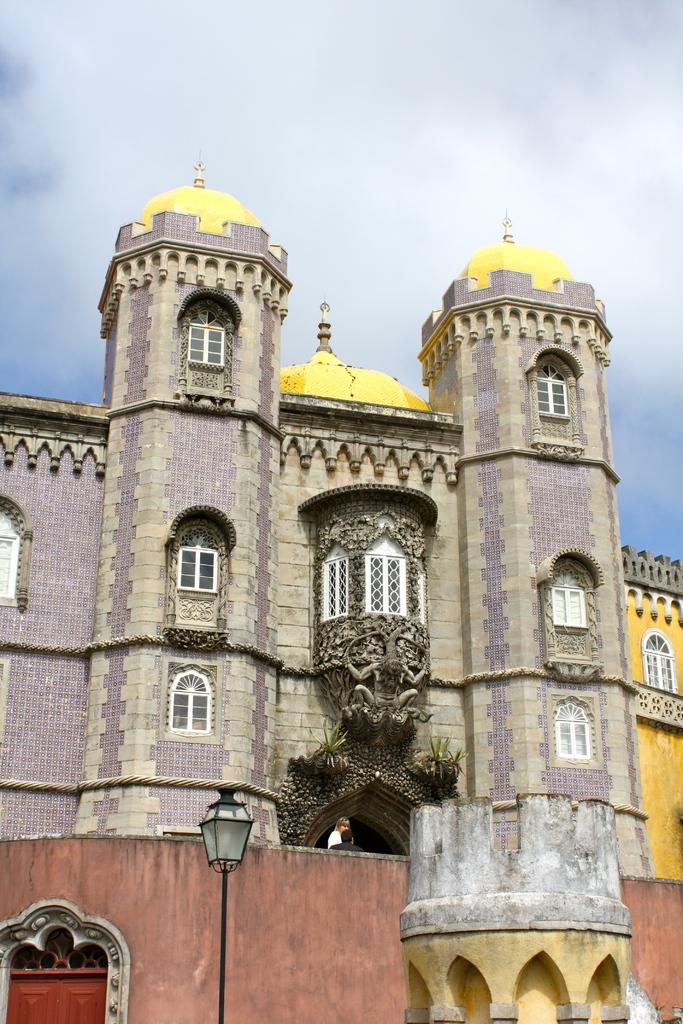What type of structure is visible in the image? There is a building in the image. How would you describe the sky in the image? The sky is slightly cloudy in the image. What can be seen at the bottom of the image? There is a street lamp at the bottom of the image. Where is the camera located in the image? There is no camera present in the image. What type of honey is being collected from the building in the image? There is no honey or beekeeping activity depicted in the image; it only shows a building and a slightly cloudy sky. 